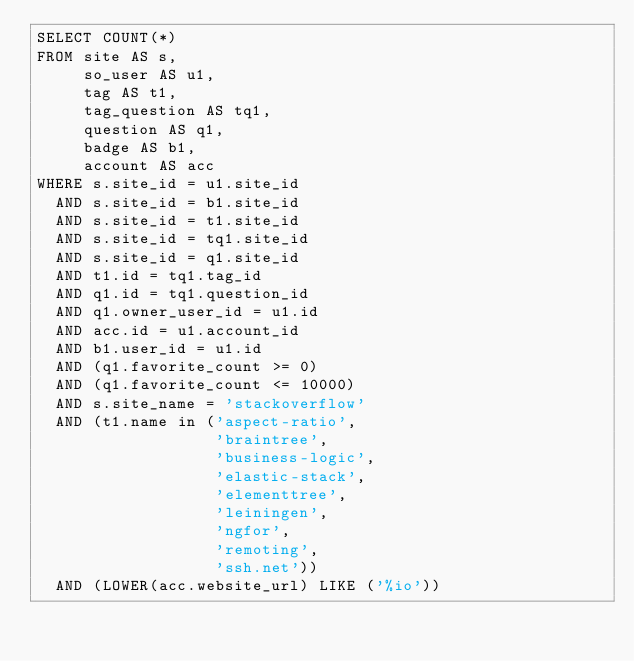Convert code to text. <code><loc_0><loc_0><loc_500><loc_500><_SQL_>SELECT COUNT(*)
FROM site AS s,
     so_user AS u1,
     tag AS t1,
     tag_question AS tq1,
     question AS q1,
     badge AS b1,
     account AS acc
WHERE s.site_id = u1.site_id
  AND s.site_id = b1.site_id
  AND s.site_id = t1.site_id
  AND s.site_id = tq1.site_id
  AND s.site_id = q1.site_id
  AND t1.id = tq1.tag_id
  AND q1.id = tq1.question_id
  AND q1.owner_user_id = u1.id
  AND acc.id = u1.account_id
  AND b1.user_id = u1.id
  AND (q1.favorite_count >= 0)
  AND (q1.favorite_count <= 10000)
  AND s.site_name = 'stackoverflow'
  AND (t1.name in ('aspect-ratio',
                   'braintree',
                   'business-logic',
                   'elastic-stack',
                   'elementtree',
                   'leiningen',
                   'ngfor',
                   'remoting',
                   'ssh.net'))
  AND (LOWER(acc.website_url) LIKE ('%io'))</code> 